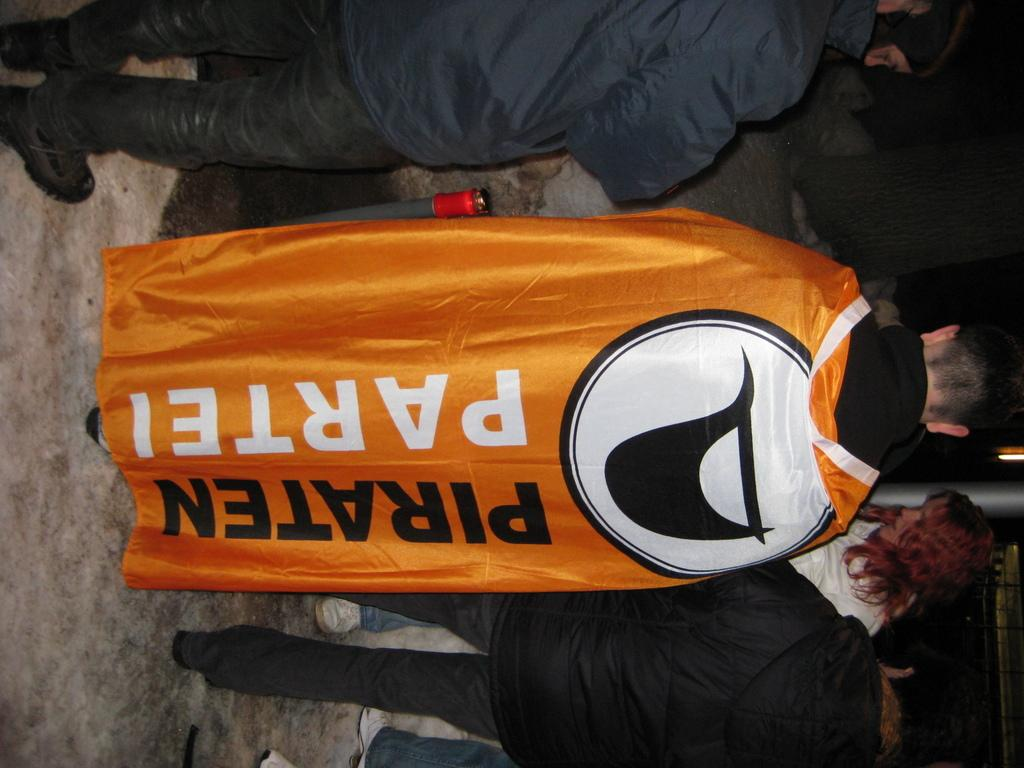Provide a one-sentence caption for the provided image. A man wears an orange Piraten Partei flag as a cape. 